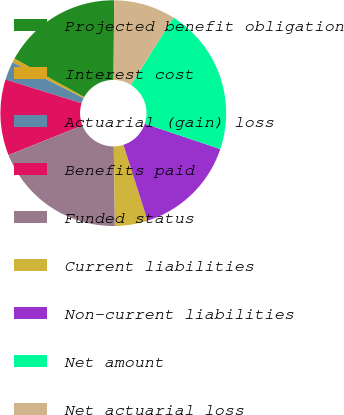Convert chart to OTSL. <chart><loc_0><loc_0><loc_500><loc_500><pie_chart><fcel>Projected benefit obligation<fcel>Interest cost<fcel>Actuarial (gain) loss<fcel>Benefits paid<fcel>Funded status<fcel>Current liabilities<fcel>Non-current liabilities<fcel>Net amount<fcel>Net actuarial loss<nl><fcel>17.11%<fcel>0.57%<fcel>2.63%<fcel>10.87%<fcel>19.17%<fcel>4.69%<fcel>14.93%<fcel>21.22%<fcel>8.81%<nl></chart> 